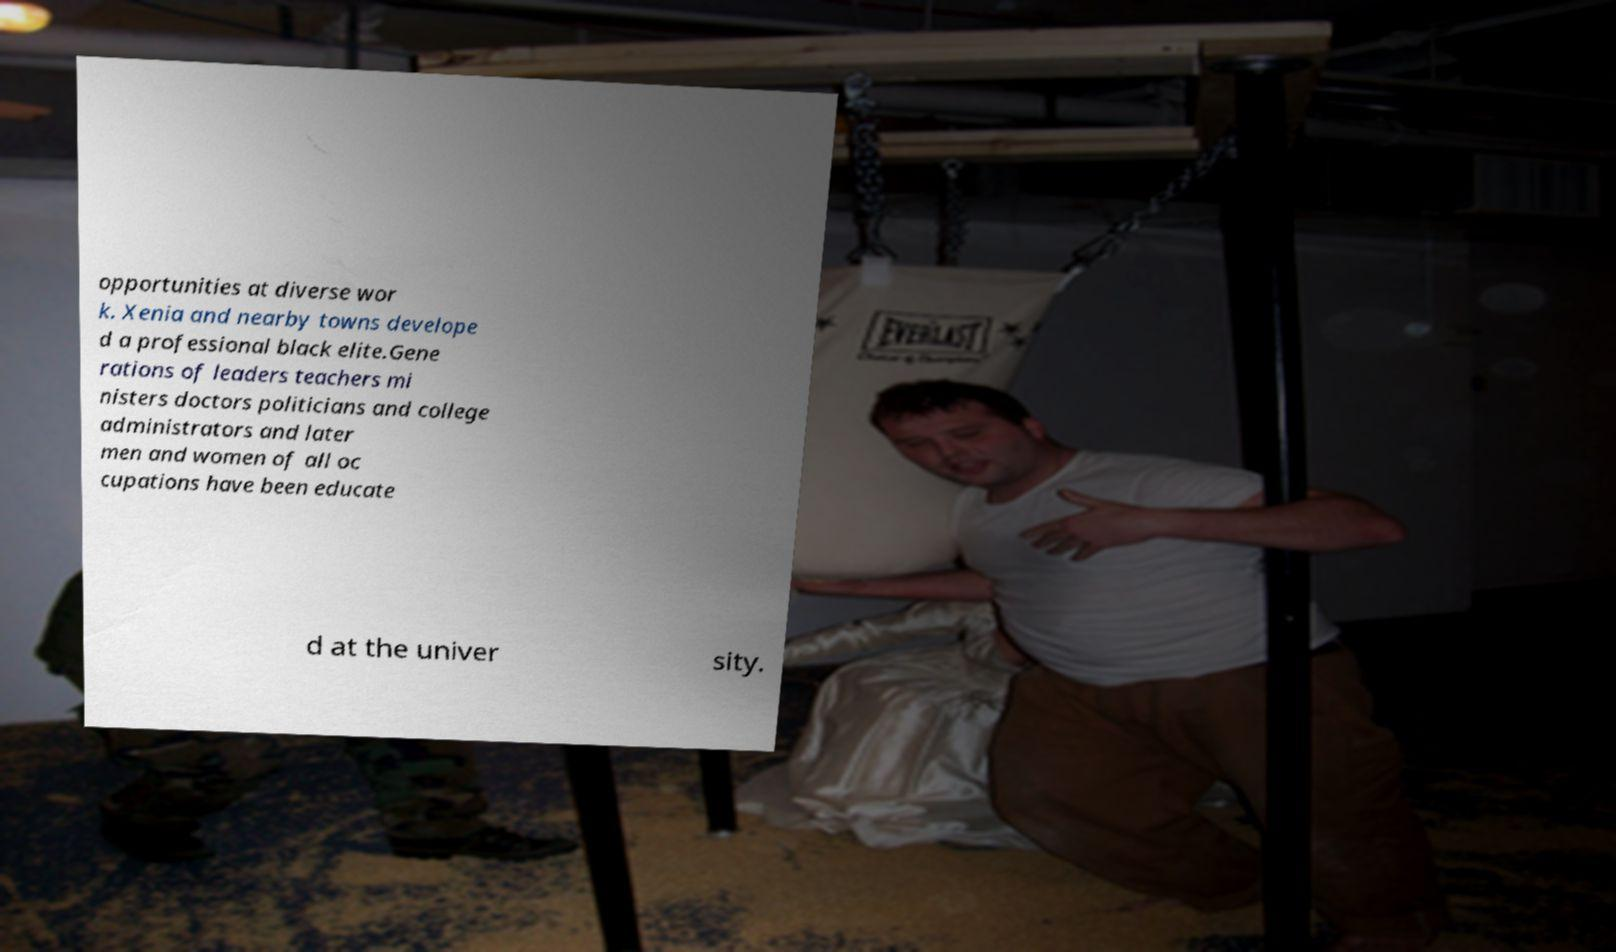Could you extract and type out the text from this image? opportunities at diverse wor k. Xenia and nearby towns develope d a professional black elite.Gene rations of leaders teachers mi nisters doctors politicians and college administrators and later men and women of all oc cupations have been educate d at the univer sity. 